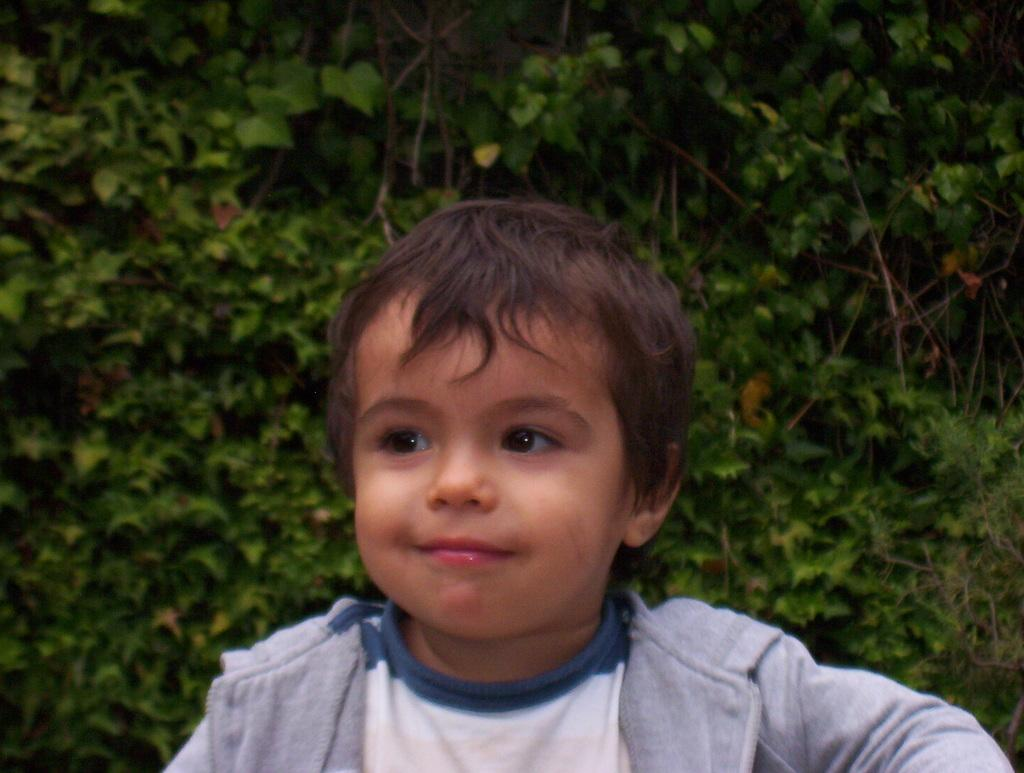Where was the image taken? The image was taken outdoors. What can be seen in the background of the image? There are plants with green leaves and stems in the background. What is the main subject of the image? There is a kid in the middle of the image. What is the expression on the kid's face? The kid has a smiling face. What type of smoke can be seen coming from the kid's mouth in the image? There is no smoke coming from the kid's mouth in the image. 